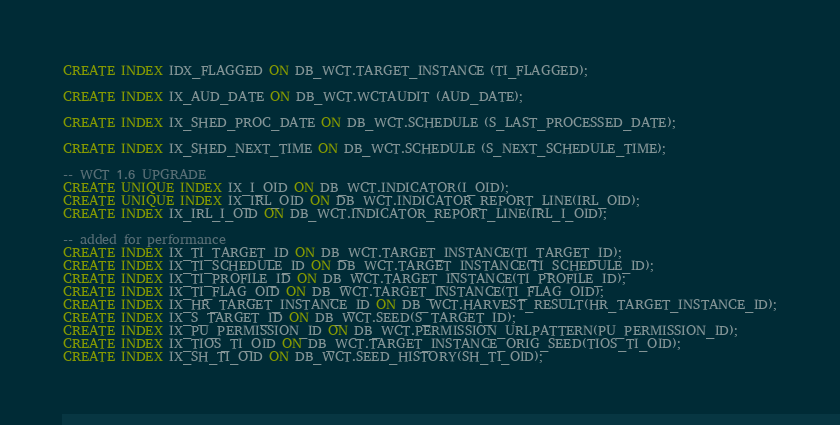Convert code to text. <code><loc_0><loc_0><loc_500><loc_500><_SQL_>CREATE INDEX IDX_FLAGGED ON DB_WCT.TARGET_INSTANCE (TI_FLAGGED);

CREATE INDEX IX_AUD_DATE ON DB_WCT.WCTAUDIT (AUD_DATE);

CREATE INDEX IX_SHED_PROC_DATE ON DB_WCT.SCHEDULE (S_LAST_PROCESSED_DATE);

CREATE INDEX IX_SHED_NEXT_TIME ON DB_WCT.SCHEDULE (S_NEXT_SCHEDULE_TIME);

-- WCT 1.6 UPGRADE
CREATE UNIQUE INDEX IX_I_OID ON DB_WCT.INDICATOR(I_OID);
CREATE UNIQUE INDEX IX_IRL_OID ON DB_WCT.INDICATOR_REPORT_LINE(IRL_OID);
CREATE INDEX IX_IRL_I_OID ON DB_WCT.INDICATOR_REPORT_LINE(IRL_I_OID);

-- added for performance
CREATE INDEX IX_TI_TARGET_ID ON DB_WCT.TARGET_INSTANCE(TI_TARGET_ID);
CREATE INDEX IX_TI_SCHEDULE_ID ON DB_WCT.TARGET_INSTANCE(TI_SCHEDULE_ID);
CREATE INDEX IX_TI_PROFILE_ID ON DB_WCT.TARGET_INSTANCE(TI_PROFILE_ID);
CREATE INDEX IX_TI_FLAG_OID ON DB_WCT.TARGET_INSTANCE(TI_FLAG_OID);
CREATE INDEX IX_HR_TARGET_INSTANCE_ID ON DB_WCT.HARVEST_RESULT(HR_TARGET_INSTANCE_ID);
CREATE INDEX IX_S_TARGET_ID ON DB_WCT.SEED(S_TARGET_ID);
CREATE INDEX IX_PU_PERMISSION_ID ON DB_WCT.PERMISSION_URLPATTERN(PU_PERMISSION_ID);
CREATE INDEX IX_TIOS_TI_OID ON DB_WCT.TARGET_INSTANCE_ORIG_SEED(TIOS_TI_OID);
CREATE INDEX IX_SH_TI_OID ON DB_WCT.SEED_HISTORY(SH_TI_OID);
</code> 